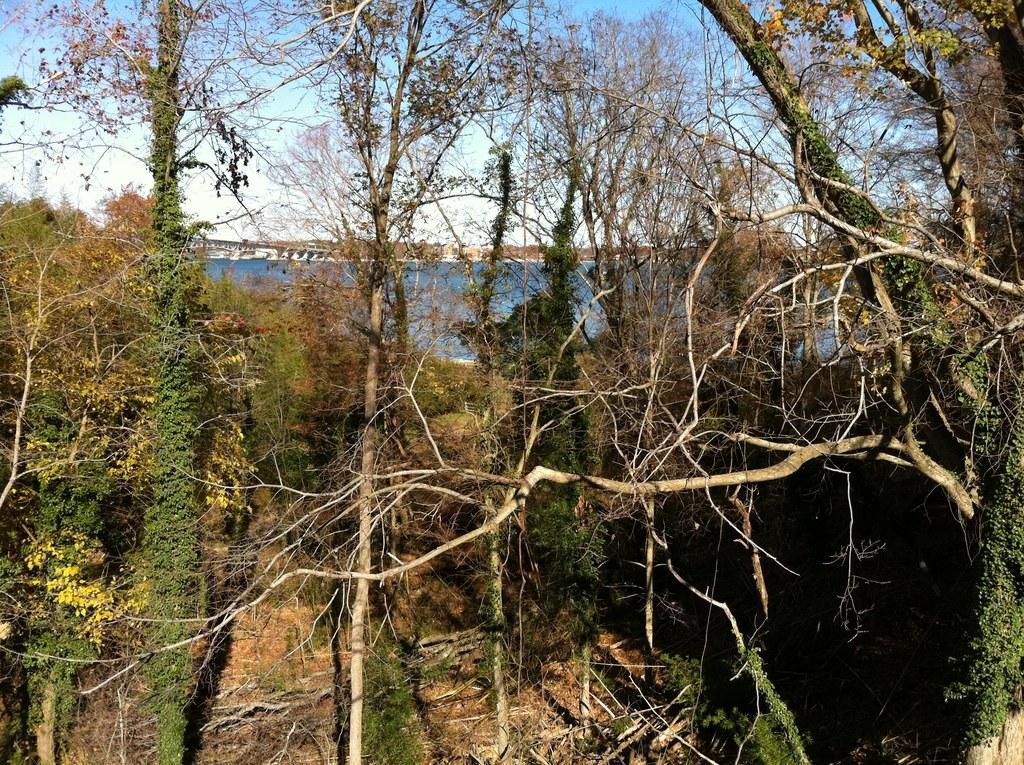What type of natural environment is visible in the foreground of the image? There is a forest with trees in the foreground of the image. What can be seen in the background of the image? There is water, a bridge, and the sky visible in the background of the image. What type of weather is suggested by the clouds in the image? The presence of clouds in the background of the image suggests that the weather might be partly cloudy. What type of net is being used to catch fish in the image? There is no net present in the image; it features a forest, water, a bridge, and clouds in the sky. 